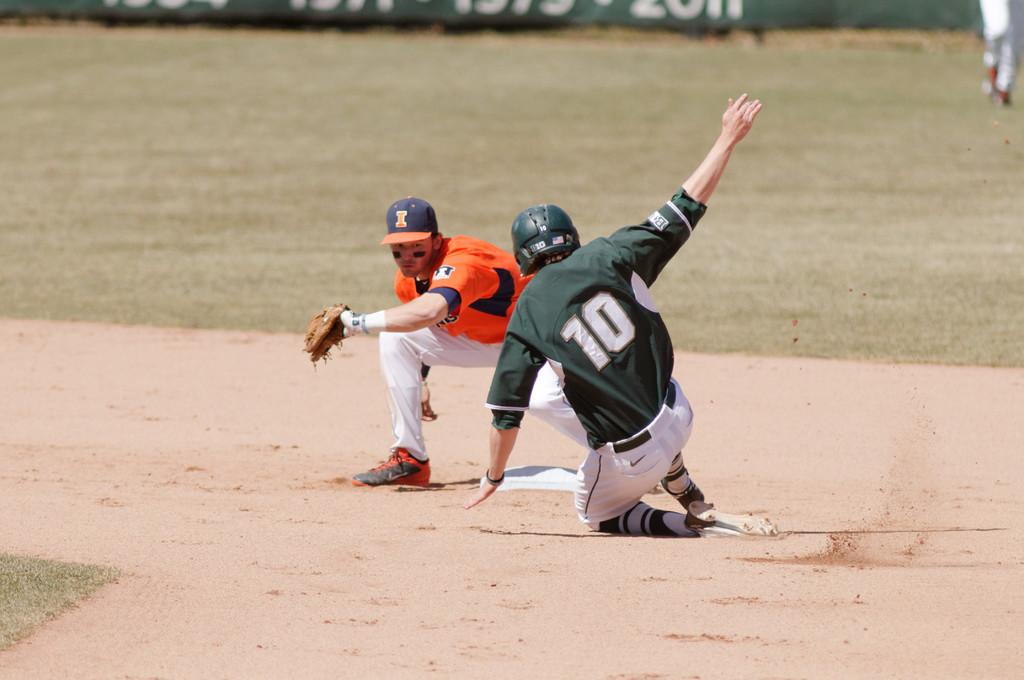<image>
Offer a succinct explanation of the picture presented. number 10 in green sliding into base while indians player waiting on the ball 